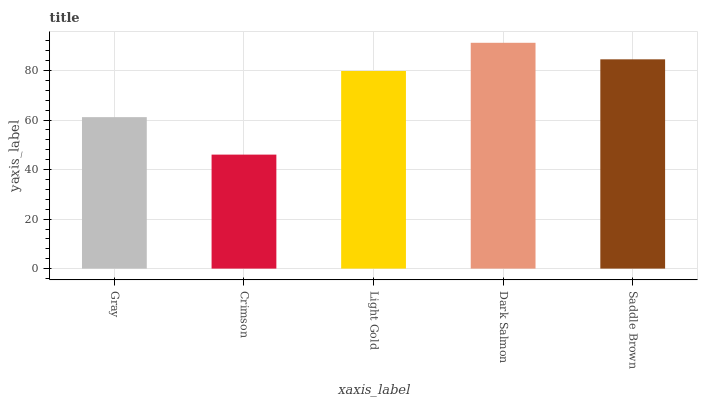Is Light Gold the minimum?
Answer yes or no. No. Is Light Gold the maximum?
Answer yes or no. No. Is Light Gold greater than Crimson?
Answer yes or no. Yes. Is Crimson less than Light Gold?
Answer yes or no. Yes. Is Crimson greater than Light Gold?
Answer yes or no. No. Is Light Gold less than Crimson?
Answer yes or no. No. Is Light Gold the high median?
Answer yes or no. Yes. Is Light Gold the low median?
Answer yes or no. Yes. Is Gray the high median?
Answer yes or no. No. Is Crimson the low median?
Answer yes or no. No. 